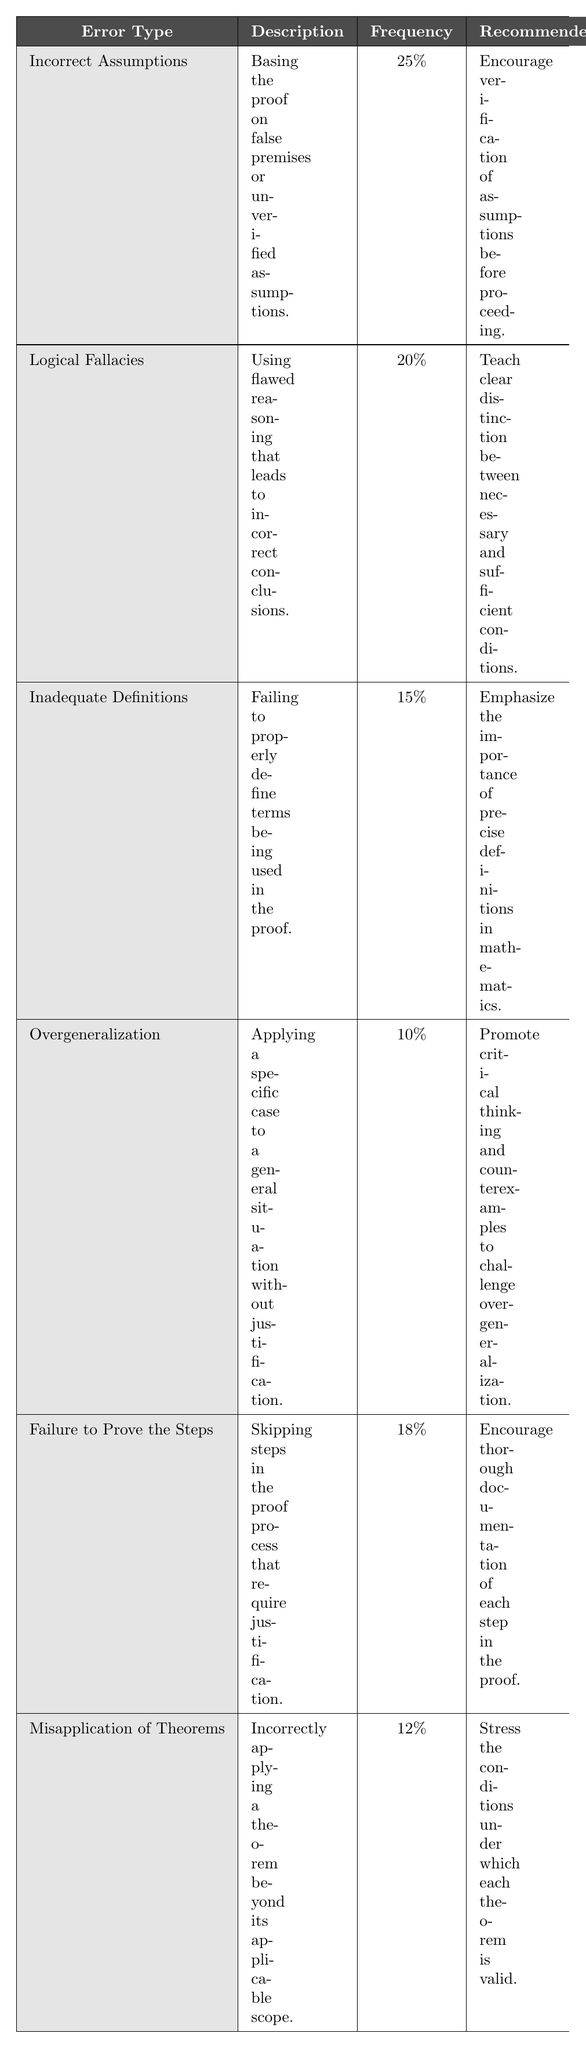What is the most common error in mathematical proofs among beginners? The most common error is "Incorrect Assumptions," which has a frequency of 25%.
Answer: Incorrect Assumptions How many errors are listed in the table? The table lists a total of 6 different common errors in mathematical proofs.
Answer: 6 What is the recommended action for addressing "Logical Fallacies"? The recommended action for addressing "Logical Fallacies" is to teach a clear distinction between necessary and sufficient conditions.
Answer: Teach clear distinction between necessary and sufficient conditions What percentage of errors does "Overgeneralization" represent in the table? "Overgeneralization" represents 10% of the errors listed in the table.
Answer: 10% What is the combined frequency percentage of "Failure to Prove the Steps" and "Misapplication of Theorems"? The combined frequency of these two errors is 18% + 12% = 30%.
Answer: 30% True or False: "Inadequate Definitions" is more common than "Misapplication of Theorems." "Inadequate Definitions" has a frequency of 15%, while "Misapplication of Theorems" has a frequency of 12%, thus it is true that "Inadequate Definitions" is more common.
Answer: True If a proof is based on false premises, which error category does it fall under? This type of error would fall under the "Incorrect Assumptions" category, which is defined as basing the proof on false premises or unverified assumptions.
Answer: Incorrect Assumptions Which two errors have the same total error frequency when summed together? "Failure to Prove the Steps" (18%) and "Inadequate Definitions" (15%) do not equal any other two errors' frequency; however, none add up to equal the frequency of another single column.
Answer: None Which recommended action is associated with "Overgeneralization"? The recommended action for "Overgeneralization" is to promote critical thinking and counterexamples to challenge overgeneralization.
Answer: Promote critical thinking and counterexamples to challenge overgeneralization What is the least frequent common error, and what is its percentage? The least frequent error is "Overgeneralization," which has a frequency of 10%.
Answer: Overgeneralization, 10% 